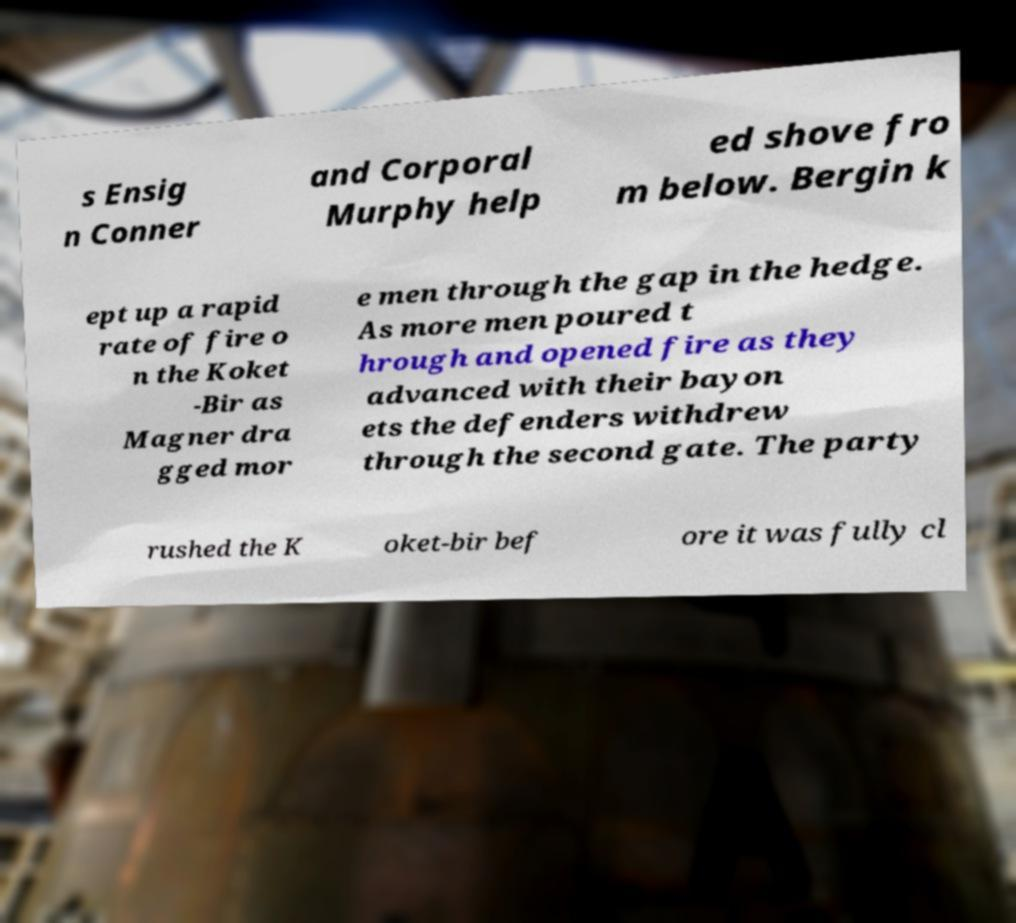Can you accurately transcribe the text from the provided image for me? s Ensig n Conner and Corporal Murphy help ed shove fro m below. Bergin k ept up a rapid rate of fire o n the Koket -Bir as Magner dra gged mor e men through the gap in the hedge. As more men poured t hrough and opened fire as they advanced with their bayon ets the defenders withdrew through the second gate. The party rushed the K oket-bir bef ore it was fully cl 